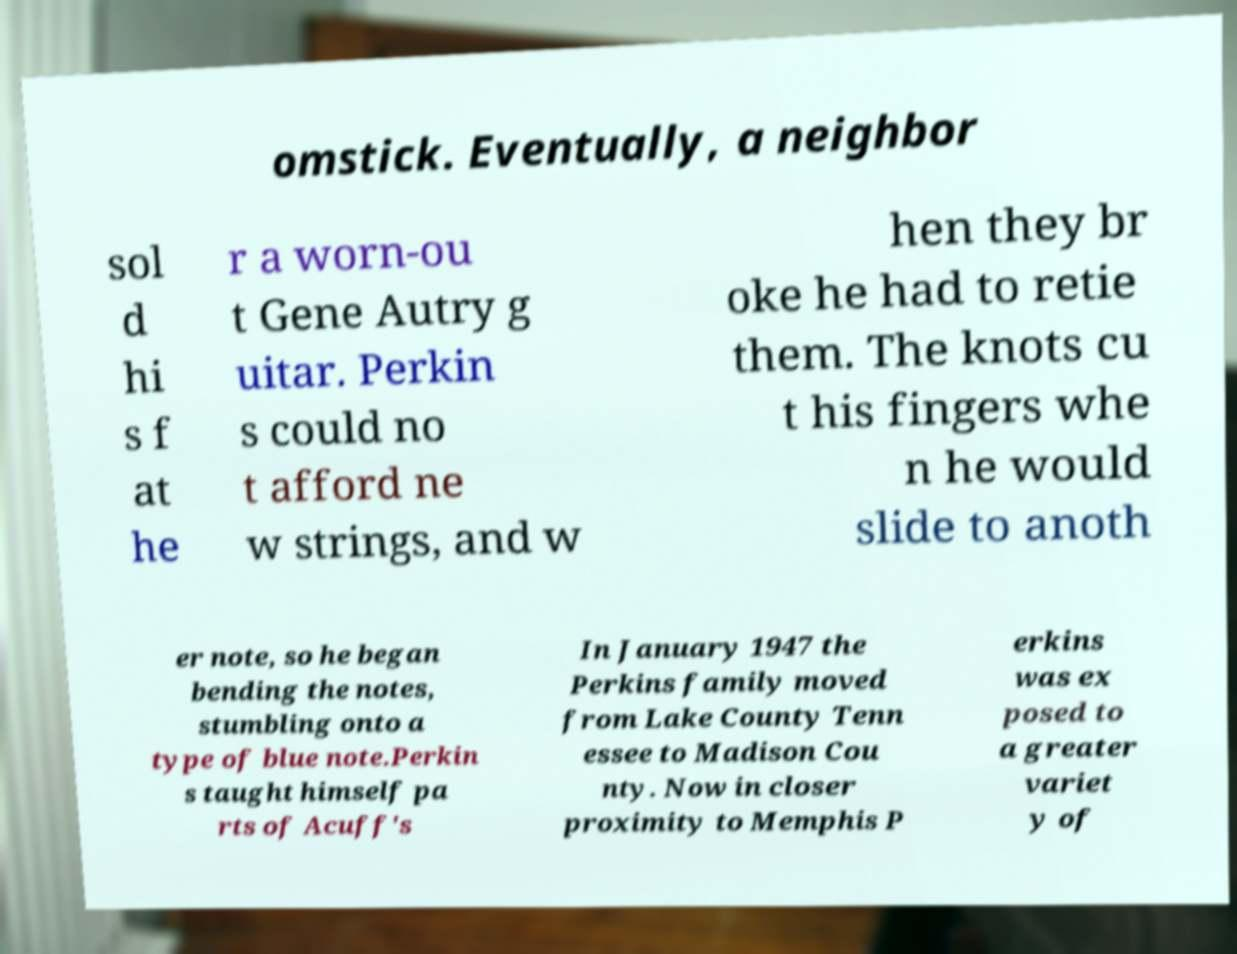There's text embedded in this image that I need extracted. Can you transcribe it verbatim? omstick. Eventually, a neighbor sol d hi s f at he r a worn-ou t Gene Autry g uitar. Perkin s could no t afford ne w strings, and w hen they br oke he had to retie them. The knots cu t his fingers whe n he would slide to anoth er note, so he began bending the notes, stumbling onto a type of blue note.Perkin s taught himself pa rts of Acuff's In January 1947 the Perkins family moved from Lake County Tenn essee to Madison Cou nty. Now in closer proximity to Memphis P erkins was ex posed to a greater variet y of 